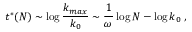Convert formula to latex. <formula><loc_0><loc_0><loc_500><loc_500>t ^ { * } ( N ) \sim \log \frac { k _ { \max } } { k _ { 0 } } \sim \frac { 1 } { \omega } \log N - \log k _ { 0 } \, ,</formula> 